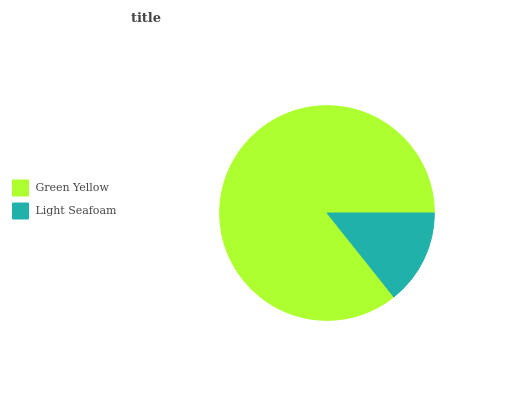Is Light Seafoam the minimum?
Answer yes or no. Yes. Is Green Yellow the maximum?
Answer yes or no. Yes. Is Light Seafoam the maximum?
Answer yes or no. No. Is Green Yellow greater than Light Seafoam?
Answer yes or no. Yes. Is Light Seafoam less than Green Yellow?
Answer yes or no. Yes. Is Light Seafoam greater than Green Yellow?
Answer yes or no. No. Is Green Yellow less than Light Seafoam?
Answer yes or no. No. Is Green Yellow the high median?
Answer yes or no. Yes. Is Light Seafoam the low median?
Answer yes or no. Yes. Is Light Seafoam the high median?
Answer yes or no. No. Is Green Yellow the low median?
Answer yes or no. No. 